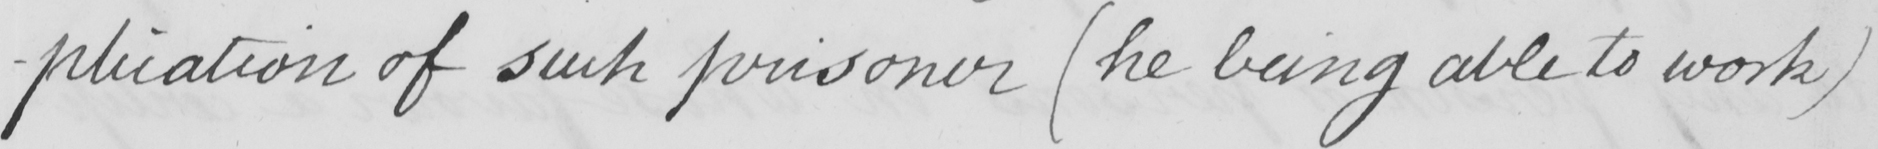Please transcribe the handwritten text in this image. -plication of such prisoner  ( he being able to work ) 